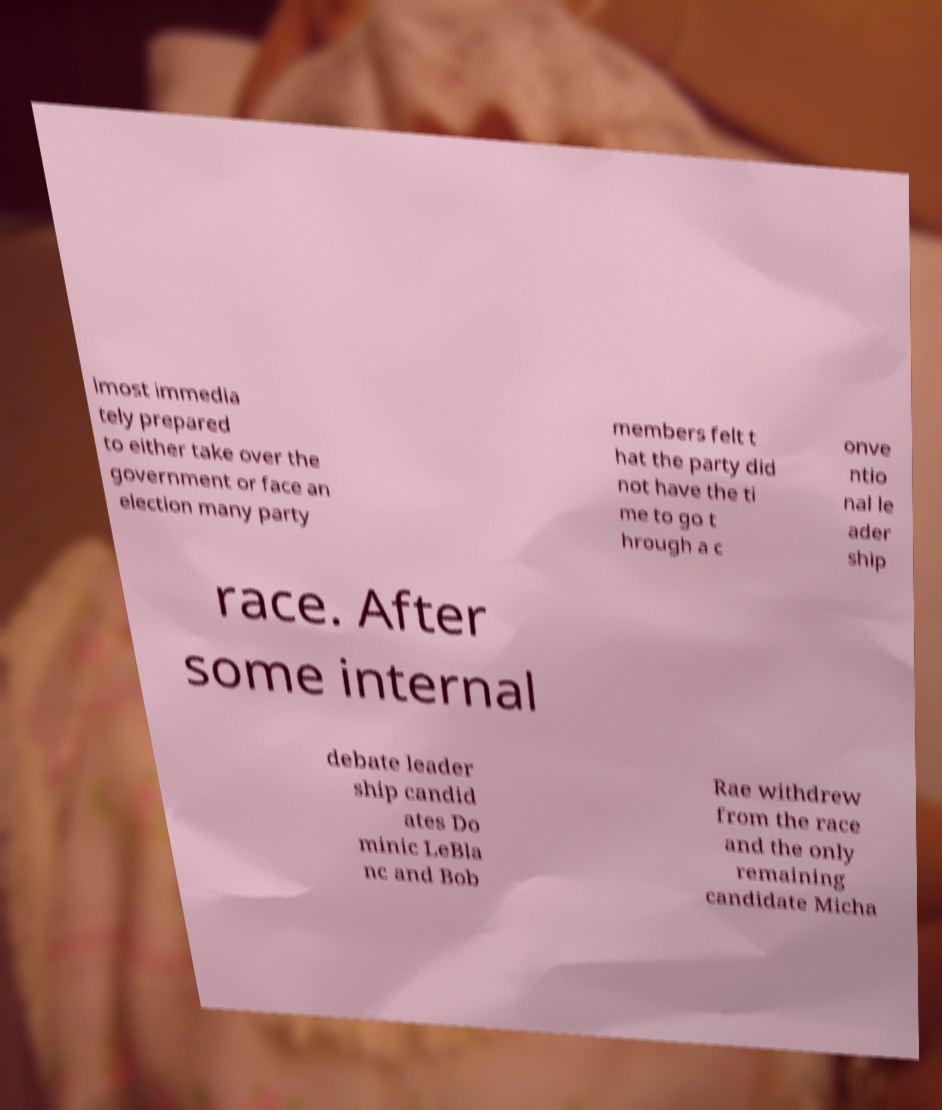Can you read and provide the text displayed in the image?This photo seems to have some interesting text. Can you extract and type it out for me? lmost immedia tely prepared to either take over the government or face an election many party members felt t hat the party did not have the ti me to go t hrough a c onve ntio nal le ader ship race. After some internal debate leader ship candid ates Do minic LeBla nc and Bob Rae withdrew from the race and the only remaining candidate Micha 